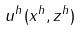Convert formula to latex. <formula><loc_0><loc_0><loc_500><loc_500>u ^ { h } ( x ^ { h } , z ^ { h } )</formula> 